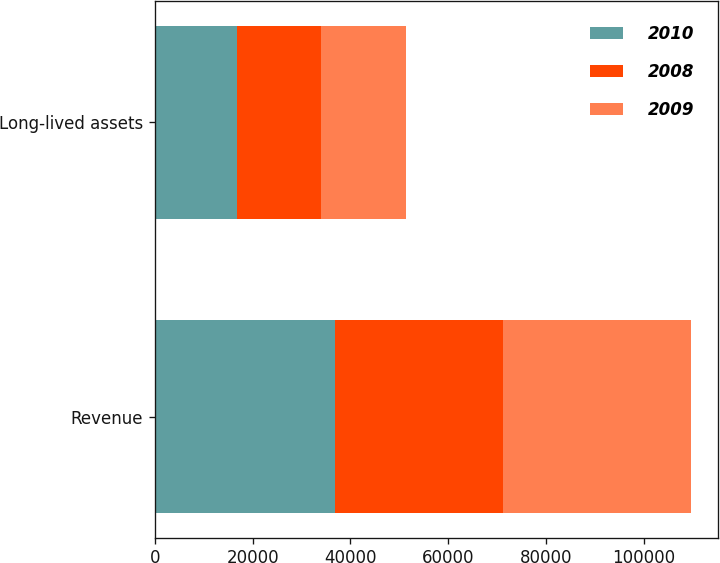Convert chart to OTSL. <chart><loc_0><loc_0><loc_500><loc_500><stacked_bar_chart><ecel><fcel>Revenue<fcel>Long-lived assets<nl><fcel>2010<fcel>36795<fcel>16693<nl><fcel>2008<fcel>34375<fcel>17336<nl><fcel>2009<fcel>38553<fcel>17422<nl></chart> 